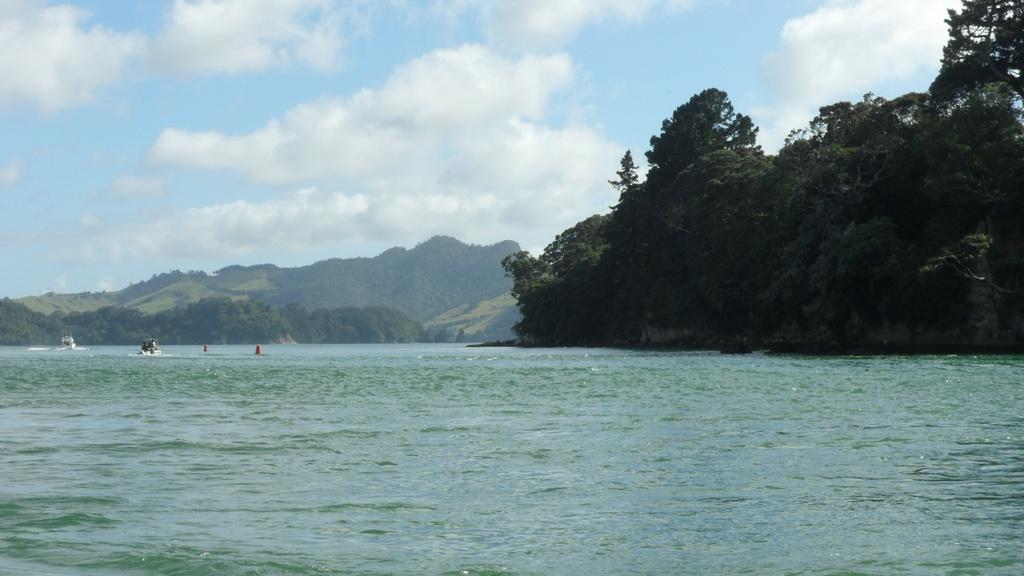Please provide a concise description of this image. In this picture we can see boats on water, trees, mountains and in the background we can see the sky with clouds. 